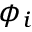Convert formula to latex. <formula><loc_0><loc_0><loc_500><loc_500>\phi _ { i }</formula> 